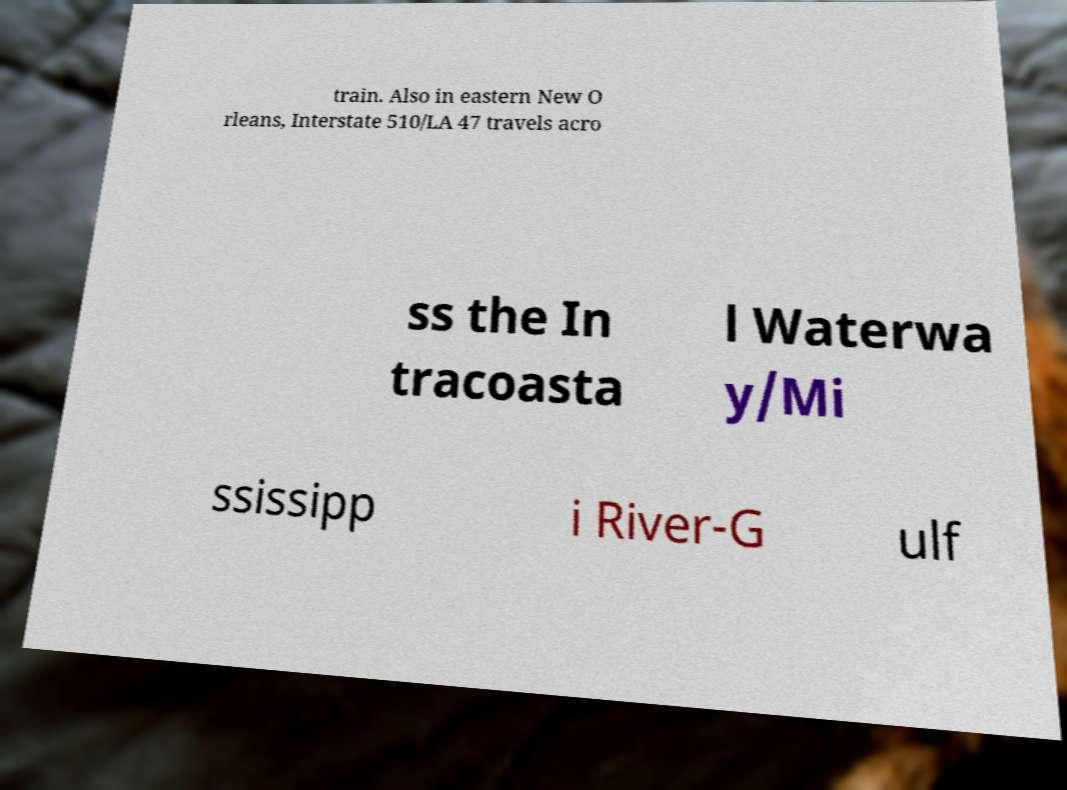What messages or text are displayed in this image? I need them in a readable, typed format. train. Also in eastern New O rleans, Interstate 510/LA 47 travels acro ss the In tracoasta l Waterwa y/Mi ssissipp i River-G ulf 